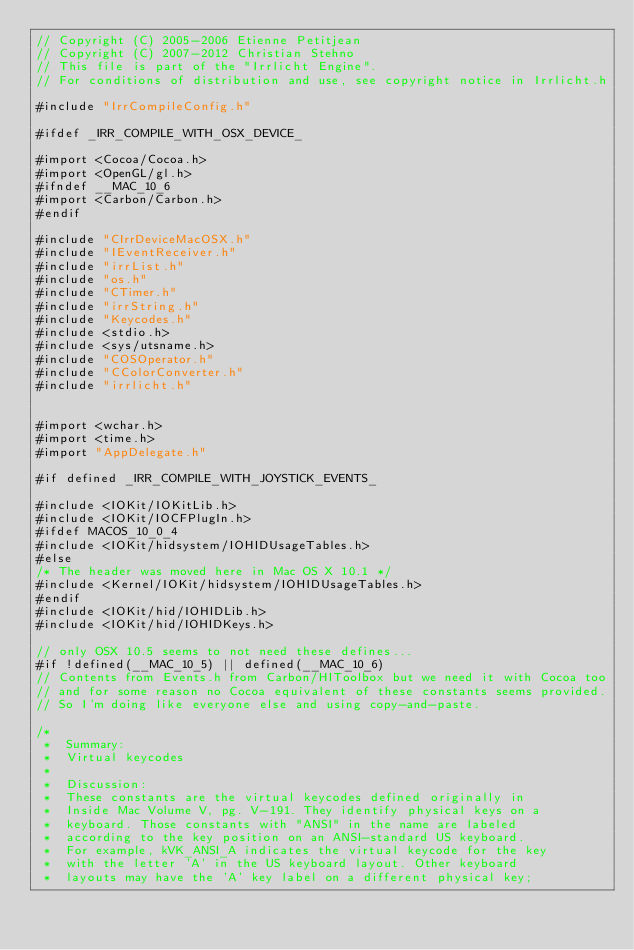<code> <loc_0><loc_0><loc_500><loc_500><_ObjectiveC_>// Copyright (C) 2005-2006 Etienne Petitjean
// Copyright (C) 2007-2012 Christian Stehno
// This file is part of the "Irrlicht Engine".
// For conditions of distribution and use, see copyright notice in Irrlicht.h

#include "IrrCompileConfig.h"

#ifdef _IRR_COMPILE_WITH_OSX_DEVICE_

#import <Cocoa/Cocoa.h>
#import <OpenGL/gl.h>
#ifndef __MAC_10_6
#import <Carbon/Carbon.h>
#endif

#include "CIrrDeviceMacOSX.h"
#include "IEventReceiver.h"
#include "irrList.h"
#include "os.h"
#include "CTimer.h"
#include "irrString.h"
#include "Keycodes.h"
#include <stdio.h>
#include <sys/utsname.h>
#include "COSOperator.h"
#include "CColorConverter.h"
#include "irrlicht.h"


#import <wchar.h>
#import <time.h>
#import "AppDelegate.h"

#if defined _IRR_COMPILE_WITH_JOYSTICK_EVENTS_

#include <IOKit/IOKitLib.h>
#include <IOKit/IOCFPlugIn.h>
#ifdef MACOS_10_0_4
#include <IOKit/hidsystem/IOHIDUsageTables.h>
#else
/* The header was moved here in Mac OS X 10.1 */
#include <Kernel/IOKit/hidsystem/IOHIDUsageTables.h>
#endif
#include <IOKit/hid/IOHIDLib.h>
#include <IOKit/hid/IOHIDKeys.h>

// only OSX 10.5 seems to not need these defines...
#if !defined(__MAC_10_5) || defined(__MAC_10_6)
// Contents from Events.h from Carbon/HIToolbox but we need it with Cocoa too
// and for some reason no Cocoa equivalent of these constants seems provided.
// So I'm doing like everyone else and using copy-and-paste.

/*
 *  Summary:
 *	Virtual keycodes
 *
 *  Discussion:
 *	These constants are the virtual keycodes defined originally in
 *	Inside Mac Volume V, pg. V-191. They identify physical keys on a
 *	keyboard. Those constants with "ANSI" in the name are labeled
 *	according to the key position on an ANSI-standard US keyboard.
 *	For example, kVK_ANSI_A indicates the virtual keycode for the key
 *	with the letter 'A' in the US keyboard layout. Other keyboard
 *	layouts may have the 'A' key label on a different physical key;</code> 